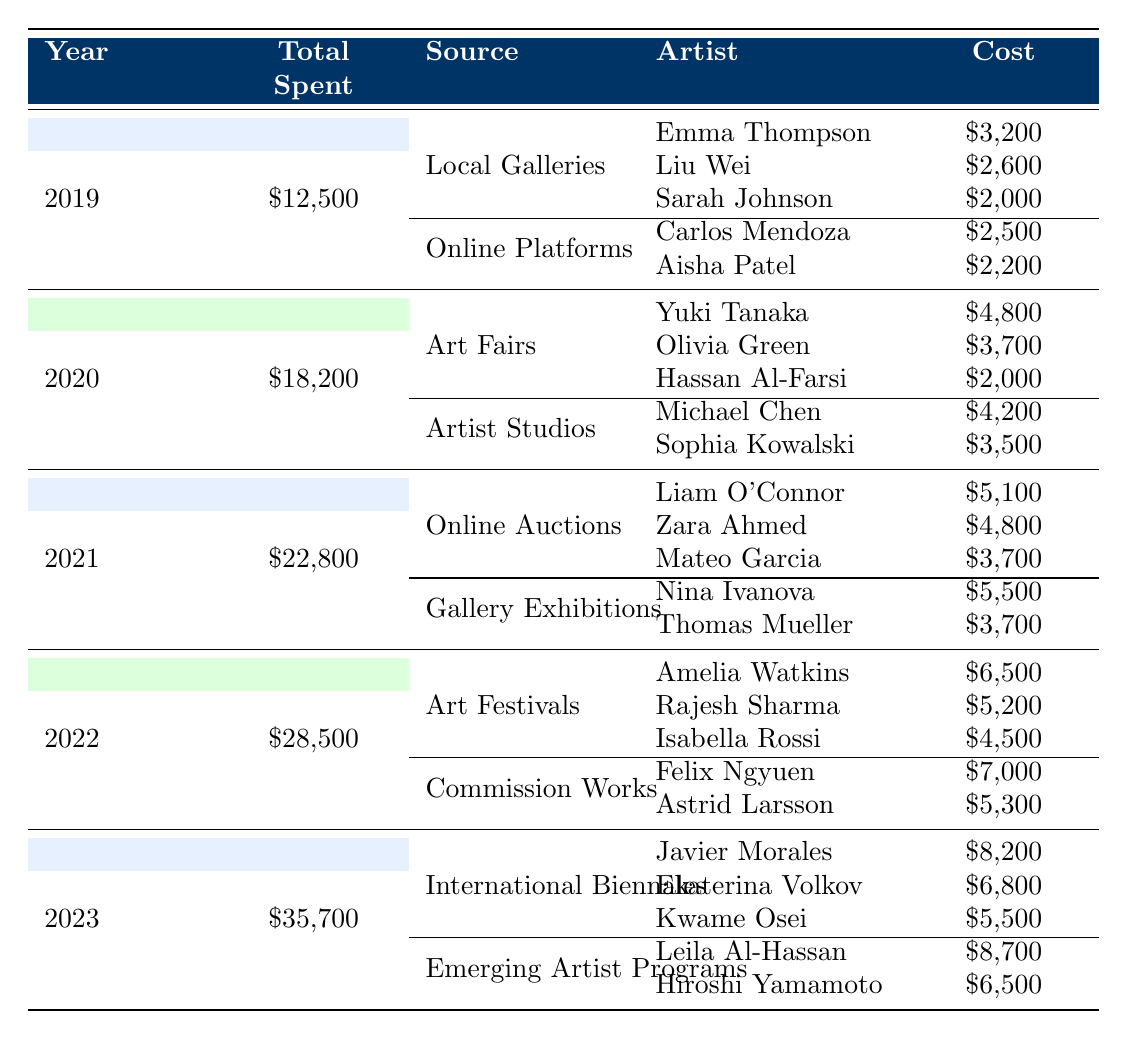What was the total amount spent on art in 2021? The table indicates that the total amount spent in 2021 is listed as "$22,800."
Answer: $22,800 Which source had the highest expenditure in 2020? In 2020, Art Fairs had a total expenditure of "$10,500," while Artist Studios had "$7,700." Since $10,500 is greater, Art Fairs is the correct source.
Answer: Art Fairs How much did you spend on online auctions in 2021? According to the table, in 2021, the expenditure for online auctions is "$13,600."
Answer: $13,600 What is the total spent on art acquisitions from 2019 to 2023? The total spent over the years is calculated as follows: $12,500 (2019) + $18,200 (2020) + $22,800 (2021) + $28,500 (2022) + $35,700 (2023) = $117,700.
Answer: $117,700 Did you spend more on commissions in 2022 than on local galleries in 2019? In 2022, commissions cost "$12,300," and in 2019, local galleries cost "$7,800." Since $12,300 is greater than $7,800, the answer is yes.
Answer: Yes What was the average cost of artworks acquired from online platforms in 2019? The total spent on online platforms in 2019 is "$4,700" for two artists. To find the average, calculate: $4,700 / 2 = $2,350.
Answer: $2,350 How much more was spent on international biennales in 2023 compared to art fairs in 2020? The expenditure on international biennales in 2023 was "$20,500" and for art fairs in 2020, it was "$10,500." The difference is $20,500 - $10,500 = $10,000.
Answer: $10,000 Who was the artist with the highest piece cost in 2022? In 2022, the highest piece cost was from Felix Ngyuen for "$7,000." Thus, he is the artist with the highest piece cost.
Answer: Felix Ngyuen What percentage of total spending in 2023 was attributed to emerging artist programs? In 2023, the total spending was "$35,700," and the amount from emerging artist programs was "$15,200." To find the percentage: ($15,200 / $35,700) * 100 = 42.6%.
Answer: 42.6% Which year saw the lowest total spending on art acquisitions? The total spending was $12,500 in 2019, which is lower than the totals for other years listed in the table.
Answer: 2019 